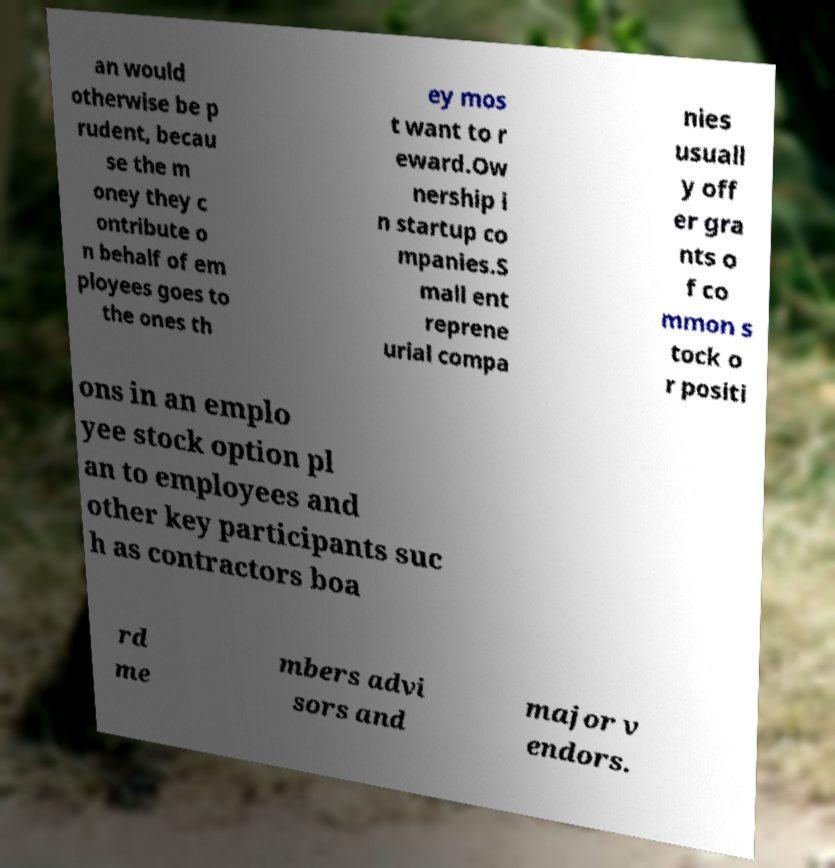Can you accurately transcribe the text from the provided image for me? an would otherwise be p rudent, becau se the m oney they c ontribute o n behalf of em ployees goes to the ones th ey mos t want to r eward.Ow nership i n startup co mpanies.S mall ent reprene urial compa nies usuall y off er gra nts o f co mmon s tock o r positi ons in an emplo yee stock option pl an to employees and other key participants suc h as contractors boa rd me mbers advi sors and major v endors. 